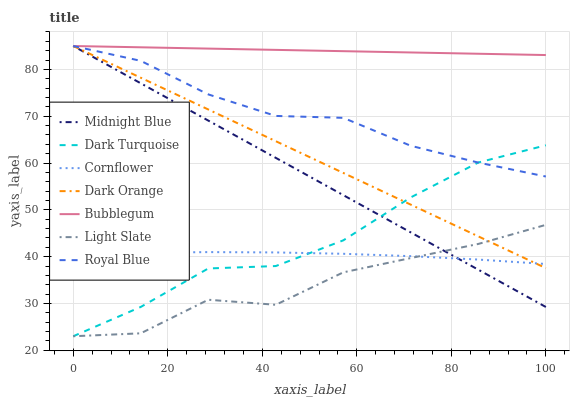Does Light Slate have the minimum area under the curve?
Answer yes or no. Yes. Does Bubblegum have the maximum area under the curve?
Answer yes or no. Yes. Does Midnight Blue have the minimum area under the curve?
Answer yes or no. No. Does Midnight Blue have the maximum area under the curve?
Answer yes or no. No. Is Bubblegum the smoothest?
Answer yes or no. Yes. Is Light Slate the roughest?
Answer yes or no. Yes. Is Midnight Blue the smoothest?
Answer yes or no. No. Is Midnight Blue the roughest?
Answer yes or no. No. Does Light Slate have the lowest value?
Answer yes or no. Yes. Does Midnight Blue have the lowest value?
Answer yes or no. No. Does Royal Blue have the highest value?
Answer yes or no. Yes. Does Cornflower have the highest value?
Answer yes or no. No. Is Dark Turquoise less than Bubblegum?
Answer yes or no. Yes. Is Royal Blue greater than Cornflower?
Answer yes or no. Yes. Does Bubblegum intersect Royal Blue?
Answer yes or no. Yes. Is Bubblegum less than Royal Blue?
Answer yes or no. No. Is Bubblegum greater than Royal Blue?
Answer yes or no. No. Does Dark Turquoise intersect Bubblegum?
Answer yes or no. No. 